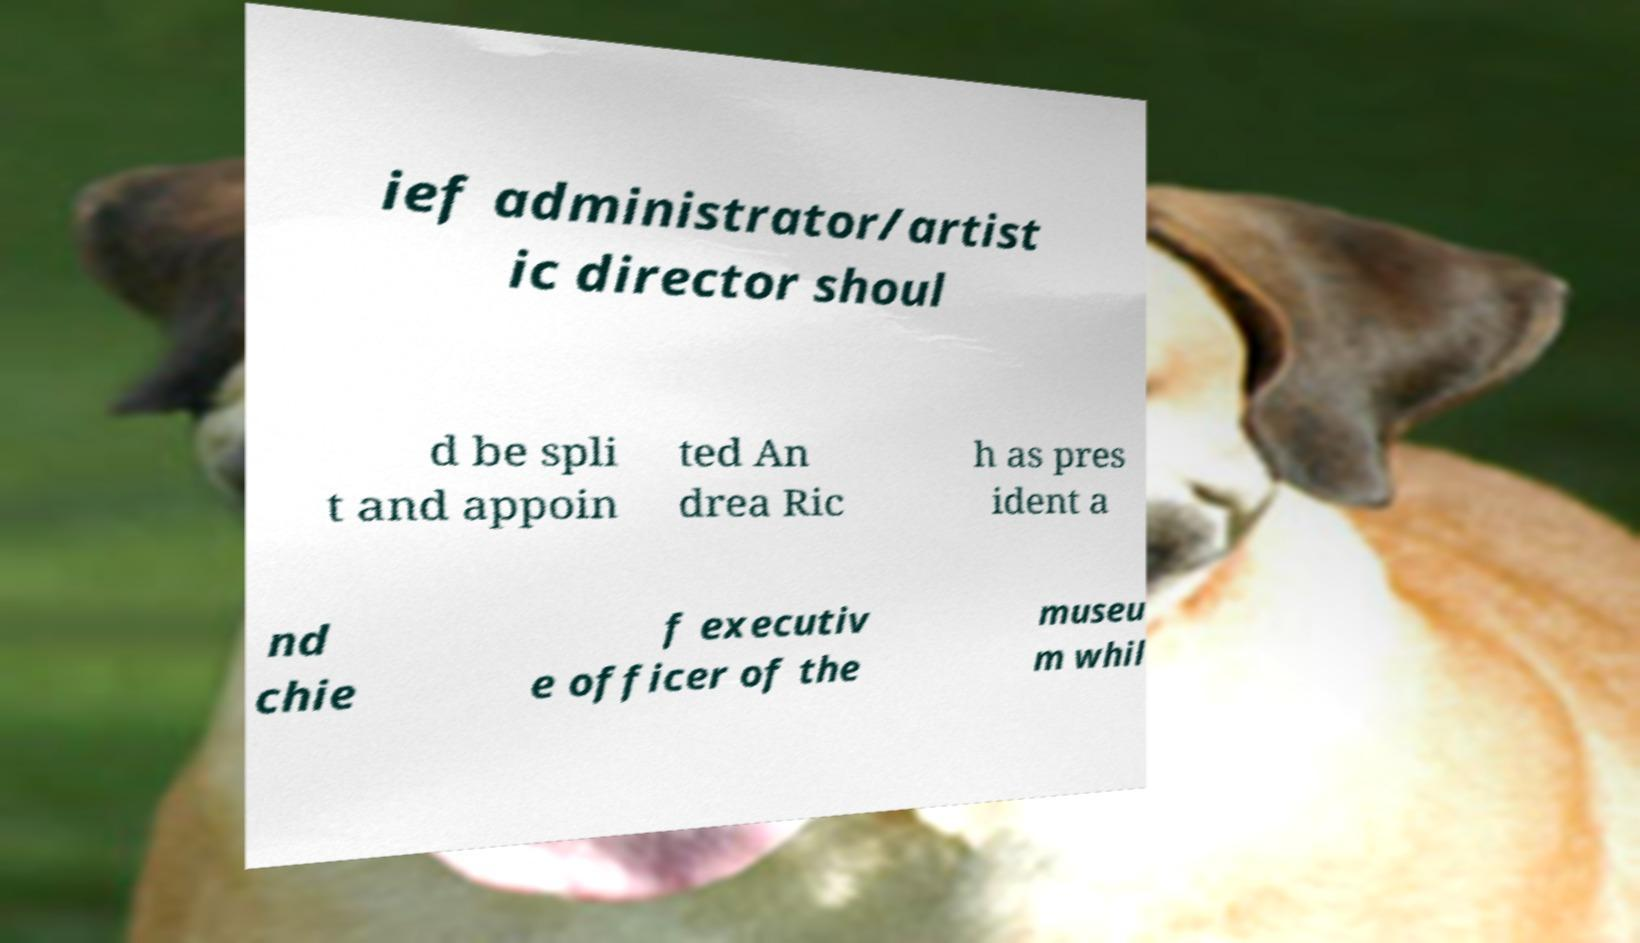I need the written content from this picture converted into text. Can you do that? ief administrator/artist ic director shoul d be spli t and appoin ted An drea Ric h as pres ident a nd chie f executiv e officer of the museu m whil 